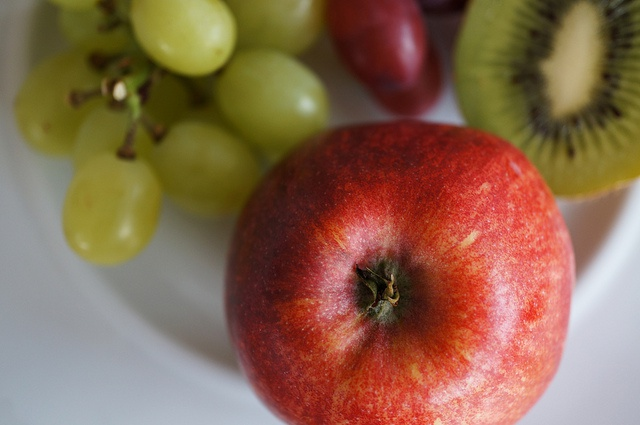Describe the objects in this image and their specific colors. I can see a apple in gray, maroon, brown, and salmon tones in this image. 